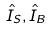Convert formula to latex. <formula><loc_0><loc_0><loc_500><loc_500>\hat { I } _ { S } , \hat { I } _ { B }</formula> 